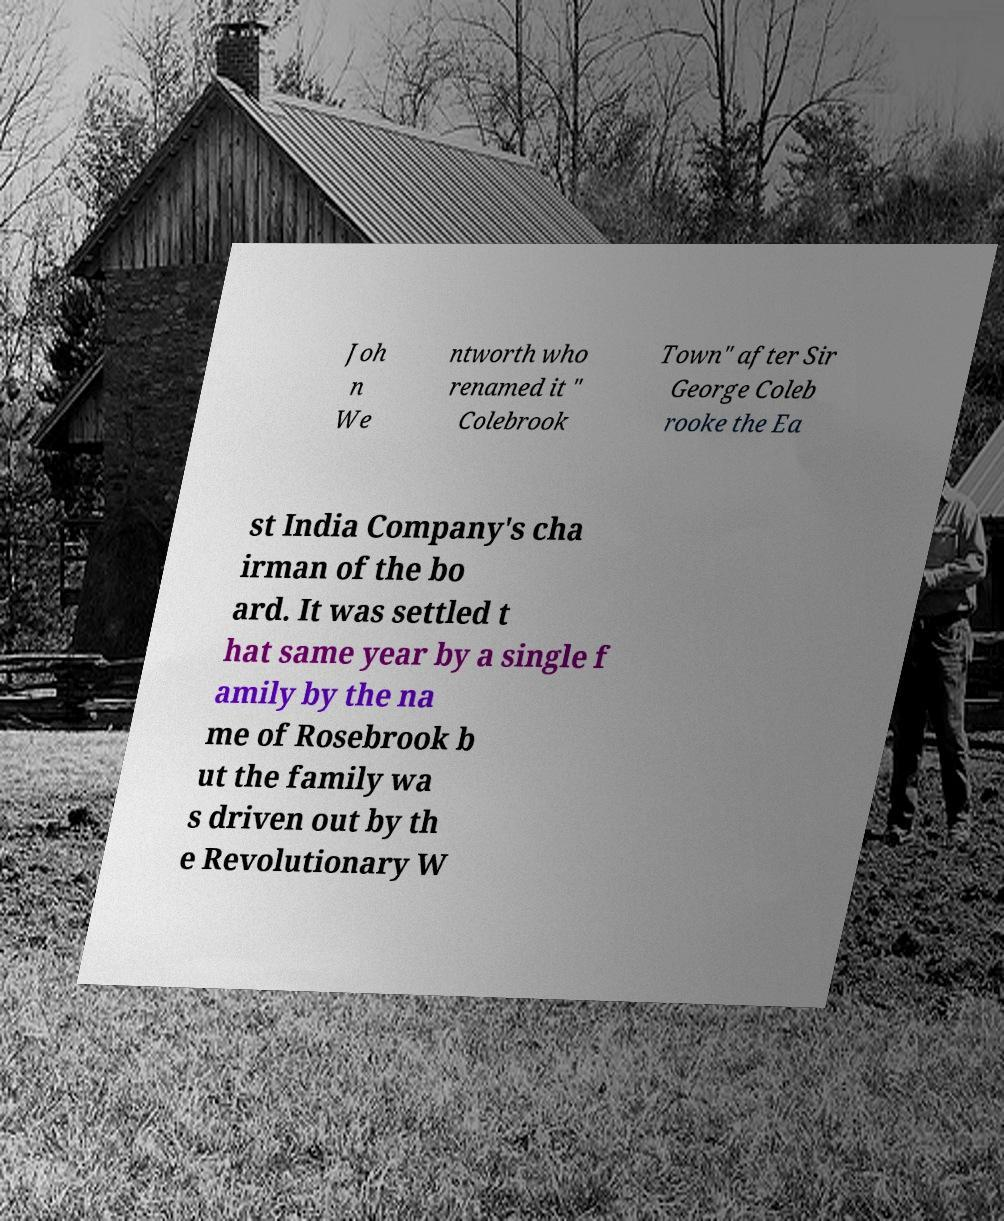What messages or text are displayed in this image? I need them in a readable, typed format. Joh n We ntworth who renamed it " Colebrook Town" after Sir George Coleb rooke the Ea st India Company's cha irman of the bo ard. It was settled t hat same year by a single f amily by the na me of Rosebrook b ut the family wa s driven out by th e Revolutionary W 